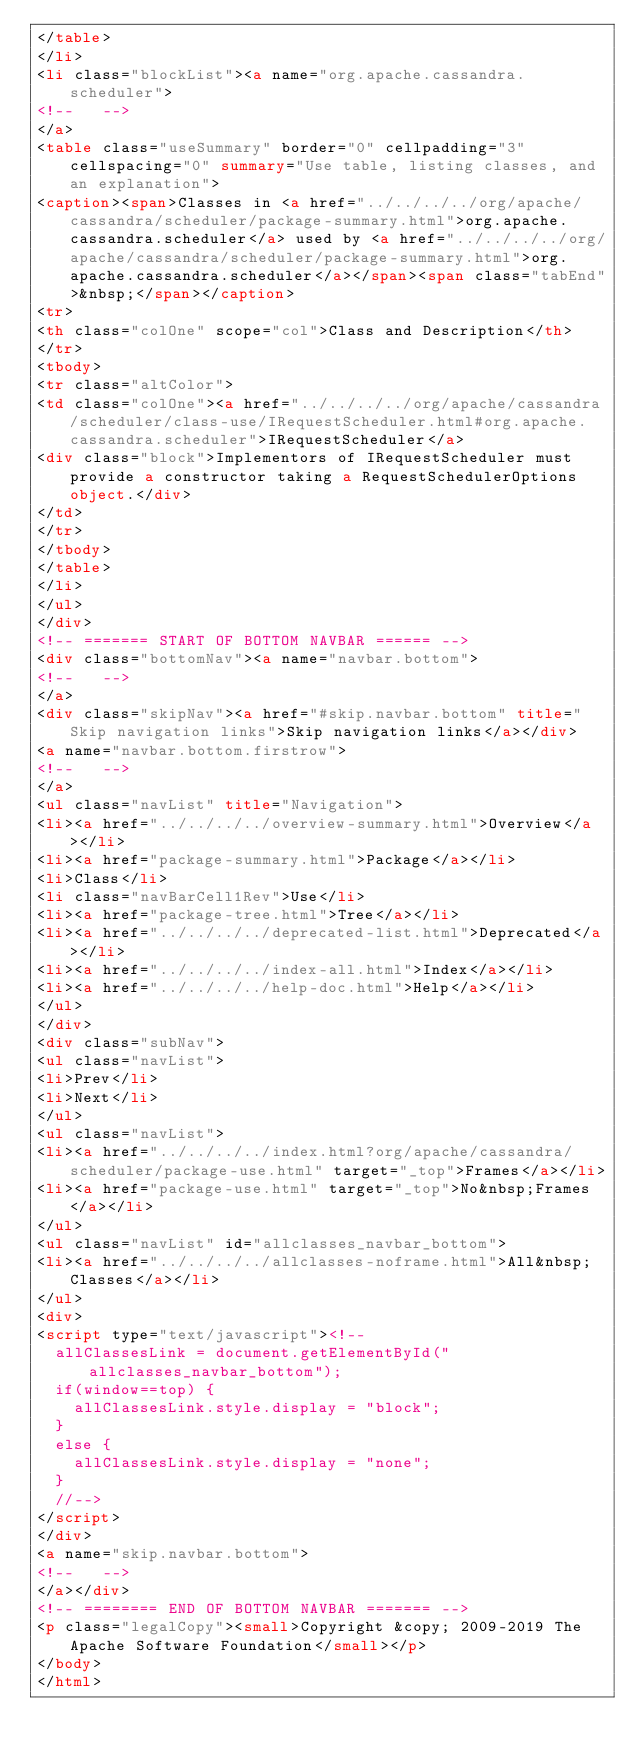Convert code to text. <code><loc_0><loc_0><loc_500><loc_500><_HTML_></table>
</li>
<li class="blockList"><a name="org.apache.cassandra.scheduler">
<!--   -->
</a>
<table class="useSummary" border="0" cellpadding="3" cellspacing="0" summary="Use table, listing classes, and an explanation">
<caption><span>Classes in <a href="../../../../org/apache/cassandra/scheduler/package-summary.html">org.apache.cassandra.scheduler</a> used by <a href="../../../../org/apache/cassandra/scheduler/package-summary.html">org.apache.cassandra.scheduler</a></span><span class="tabEnd">&nbsp;</span></caption>
<tr>
<th class="colOne" scope="col">Class and Description</th>
</tr>
<tbody>
<tr class="altColor">
<td class="colOne"><a href="../../../../org/apache/cassandra/scheduler/class-use/IRequestScheduler.html#org.apache.cassandra.scheduler">IRequestScheduler</a>
<div class="block">Implementors of IRequestScheduler must provide a constructor taking a RequestSchedulerOptions object.</div>
</td>
</tr>
</tbody>
</table>
</li>
</ul>
</div>
<!-- ======= START OF BOTTOM NAVBAR ====== -->
<div class="bottomNav"><a name="navbar.bottom">
<!--   -->
</a>
<div class="skipNav"><a href="#skip.navbar.bottom" title="Skip navigation links">Skip navigation links</a></div>
<a name="navbar.bottom.firstrow">
<!--   -->
</a>
<ul class="navList" title="Navigation">
<li><a href="../../../../overview-summary.html">Overview</a></li>
<li><a href="package-summary.html">Package</a></li>
<li>Class</li>
<li class="navBarCell1Rev">Use</li>
<li><a href="package-tree.html">Tree</a></li>
<li><a href="../../../../deprecated-list.html">Deprecated</a></li>
<li><a href="../../../../index-all.html">Index</a></li>
<li><a href="../../../../help-doc.html">Help</a></li>
</ul>
</div>
<div class="subNav">
<ul class="navList">
<li>Prev</li>
<li>Next</li>
</ul>
<ul class="navList">
<li><a href="../../../../index.html?org/apache/cassandra/scheduler/package-use.html" target="_top">Frames</a></li>
<li><a href="package-use.html" target="_top">No&nbsp;Frames</a></li>
</ul>
<ul class="navList" id="allclasses_navbar_bottom">
<li><a href="../../../../allclasses-noframe.html">All&nbsp;Classes</a></li>
</ul>
<div>
<script type="text/javascript"><!--
  allClassesLink = document.getElementById("allclasses_navbar_bottom");
  if(window==top) {
    allClassesLink.style.display = "block";
  }
  else {
    allClassesLink.style.display = "none";
  }
  //-->
</script>
</div>
<a name="skip.navbar.bottom">
<!--   -->
</a></div>
<!-- ======== END OF BOTTOM NAVBAR ======= -->
<p class="legalCopy"><small>Copyright &copy; 2009-2019 The Apache Software Foundation</small></p>
</body>
</html>
</code> 